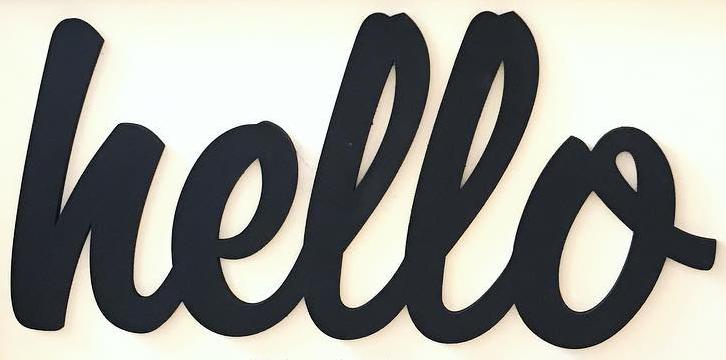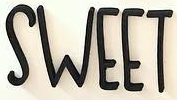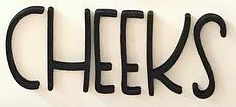Read the text from these images in sequence, separated by a semicolon. hello; SWEET; CHEEKS 